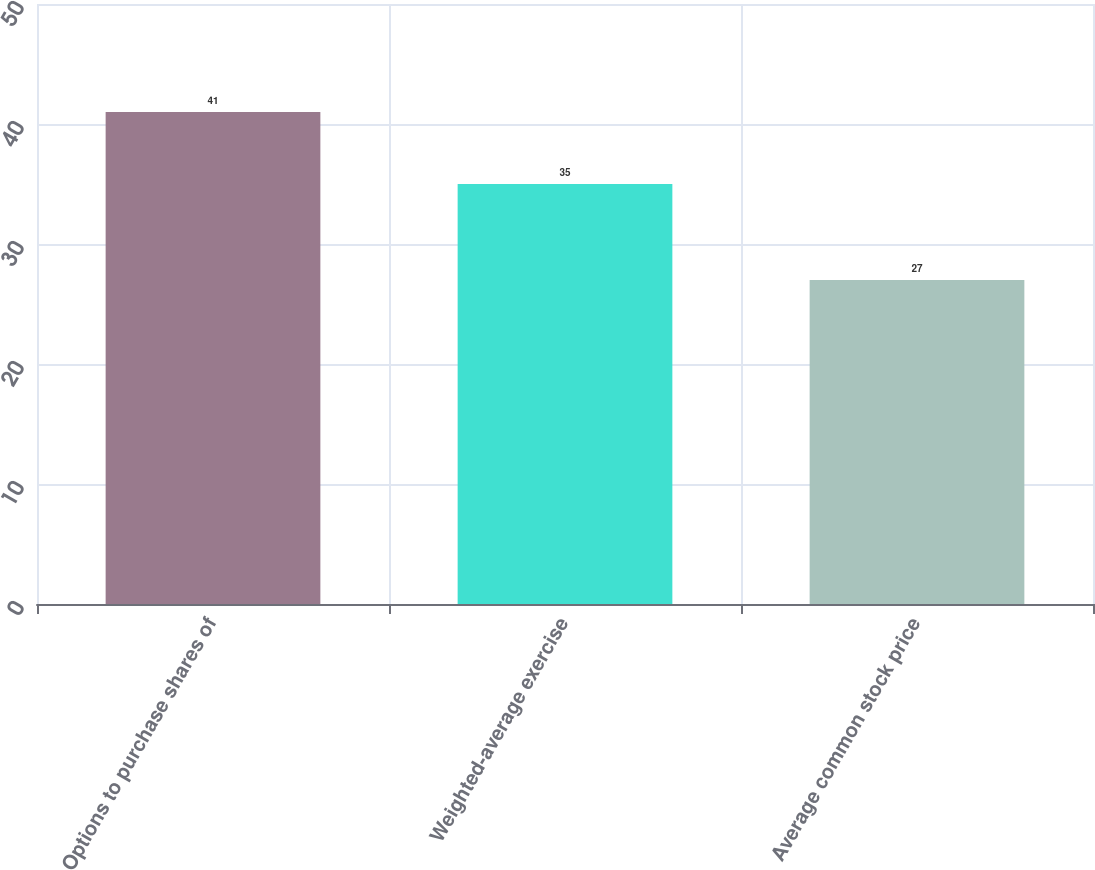Convert chart to OTSL. <chart><loc_0><loc_0><loc_500><loc_500><bar_chart><fcel>Options to purchase shares of<fcel>Weighted-average exercise<fcel>Average common stock price<nl><fcel>41<fcel>35<fcel>27<nl></chart> 